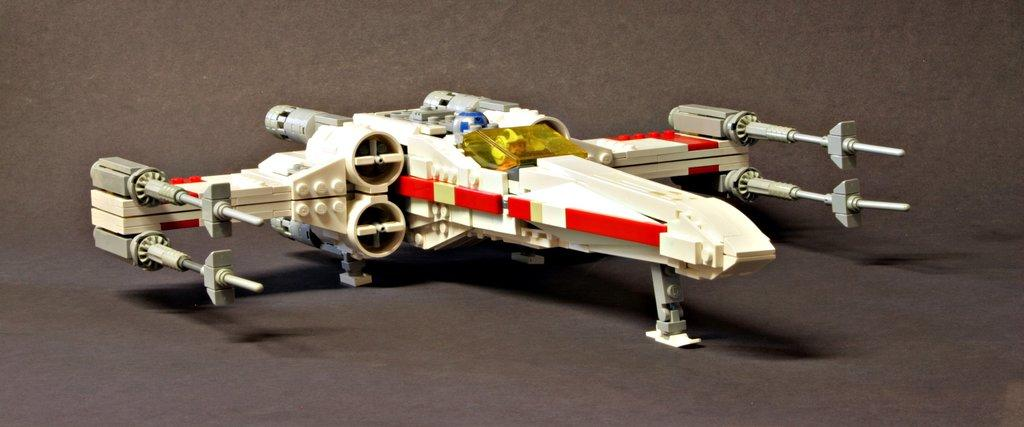What is the main subject of the image? The main subject of the image is a miniature aircraft. What colors can be seen on the aircraft? The aircraft has white, red, and ash colors. What is the surface beneath the aircraft? The aircraft is on a black surface. What type of soda can be seen in the image? There is no soda present in the image. Is there an alarm going off in the image? There is no alarm present in the image. 